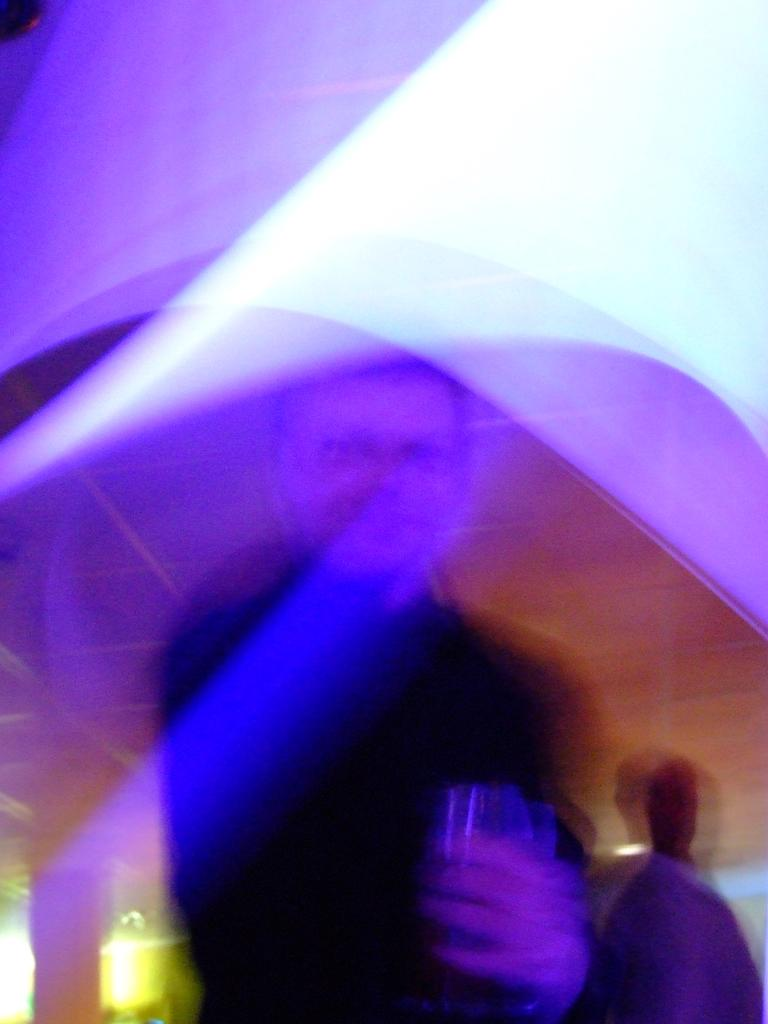How many people are in the image? There are two persons in the image. What is one of the persons holding in their hand? One person is holding a glass in their hand. What type of rice can be seen in the image? There is no rice present in the image. What type of camera is being used to take the picture? The image does not show any camera being used to take the picture. 